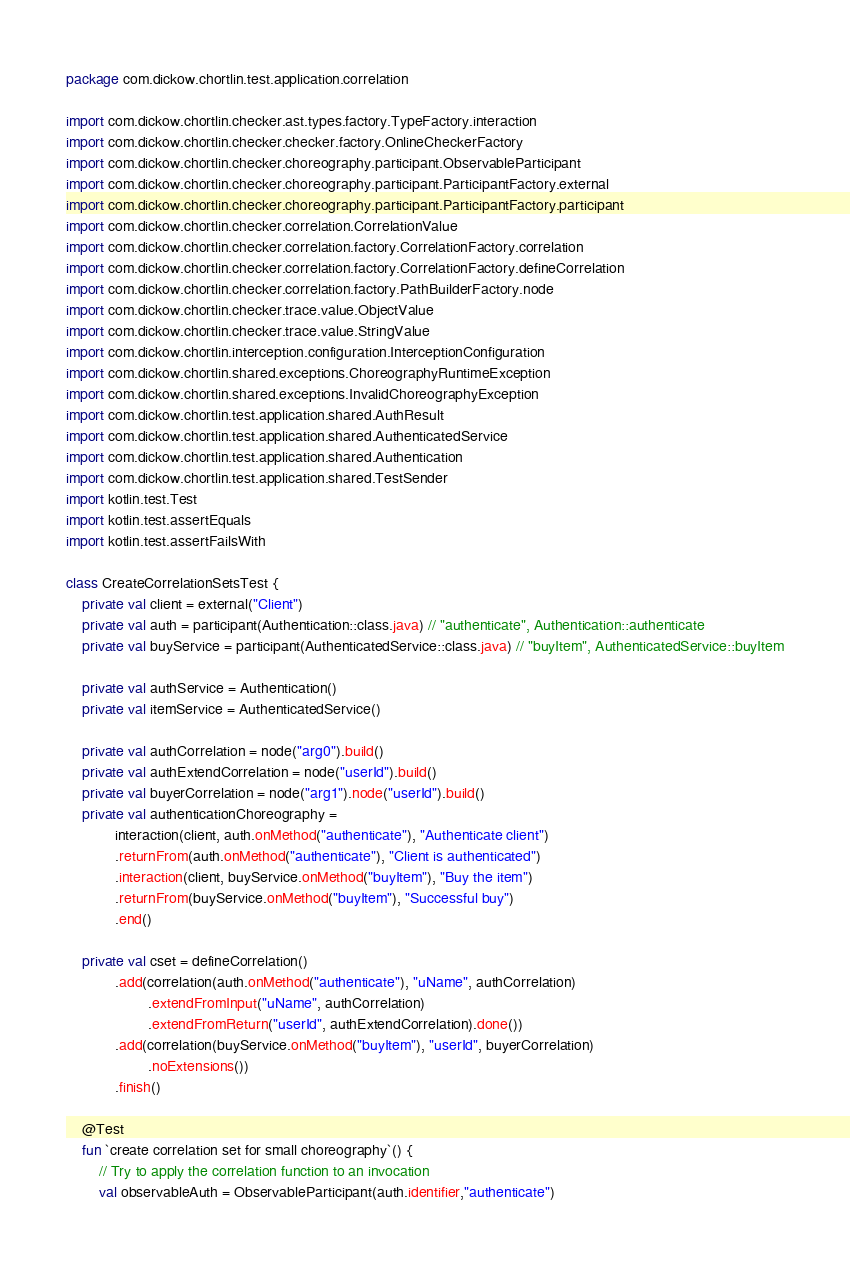Convert code to text. <code><loc_0><loc_0><loc_500><loc_500><_Kotlin_>package com.dickow.chortlin.test.application.correlation

import com.dickow.chortlin.checker.ast.types.factory.TypeFactory.interaction
import com.dickow.chortlin.checker.checker.factory.OnlineCheckerFactory
import com.dickow.chortlin.checker.choreography.participant.ObservableParticipant
import com.dickow.chortlin.checker.choreography.participant.ParticipantFactory.external
import com.dickow.chortlin.checker.choreography.participant.ParticipantFactory.participant
import com.dickow.chortlin.checker.correlation.CorrelationValue
import com.dickow.chortlin.checker.correlation.factory.CorrelationFactory.correlation
import com.dickow.chortlin.checker.correlation.factory.CorrelationFactory.defineCorrelation
import com.dickow.chortlin.checker.correlation.factory.PathBuilderFactory.node
import com.dickow.chortlin.checker.trace.value.ObjectValue
import com.dickow.chortlin.checker.trace.value.StringValue
import com.dickow.chortlin.interception.configuration.InterceptionConfiguration
import com.dickow.chortlin.shared.exceptions.ChoreographyRuntimeException
import com.dickow.chortlin.shared.exceptions.InvalidChoreographyException
import com.dickow.chortlin.test.application.shared.AuthResult
import com.dickow.chortlin.test.application.shared.AuthenticatedService
import com.dickow.chortlin.test.application.shared.Authentication
import com.dickow.chortlin.test.application.shared.TestSender
import kotlin.test.Test
import kotlin.test.assertEquals
import kotlin.test.assertFailsWith

class CreateCorrelationSetsTest {
    private val client = external("Client")
    private val auth = participant(Authentication::class.java) // "authenticate", Authentication::authenticate
    private val buyService = participant(AuthenticatedService::class.java) // "buyItem", AuthenticatedService::buyItem

    private val authService = Authentication()
    private val itemService = AuthenticatedService()

    private val authCorrelation = node("arg0").build()
    private val authExtendCorrelation = node("userId").build()
    private val buyerCorrelation = node("arg1").node("userId").build()
    private val authenticationChoreography =
            interaction(client, auth.onMethod("authenticate"), "Authenticate client")
            .returnFrom(auth.onMethod("authenticate"), "Client is authenticated")
            .interaction(client, buyService.onMethod("buyItem"), "Buy the item")
            .returnFrom(buyService.onMethod("buyItem"), "Successful buy")
            .end()

    private val cset = defineCorrelation()
            .add(correlation(auth.onMethod("authenticate"), "uName", authCorrelation)
                    .extendFromInput("uName", authCorrelation)
                    .extendFromReturn("userId", authExtendCorrelation).done())
            .add(correlation(buyService.onMethod("buyItem"), "userId", buyerCorrelation)
                    .noExtensions())
            .finish()

    @Test
    fun `create correlation set for small choreography`() {
        // Try to apply the correlation function to an invocation
        val observableAuth = ObservableParticipant(auth.identifier,"authenticate")</code> 